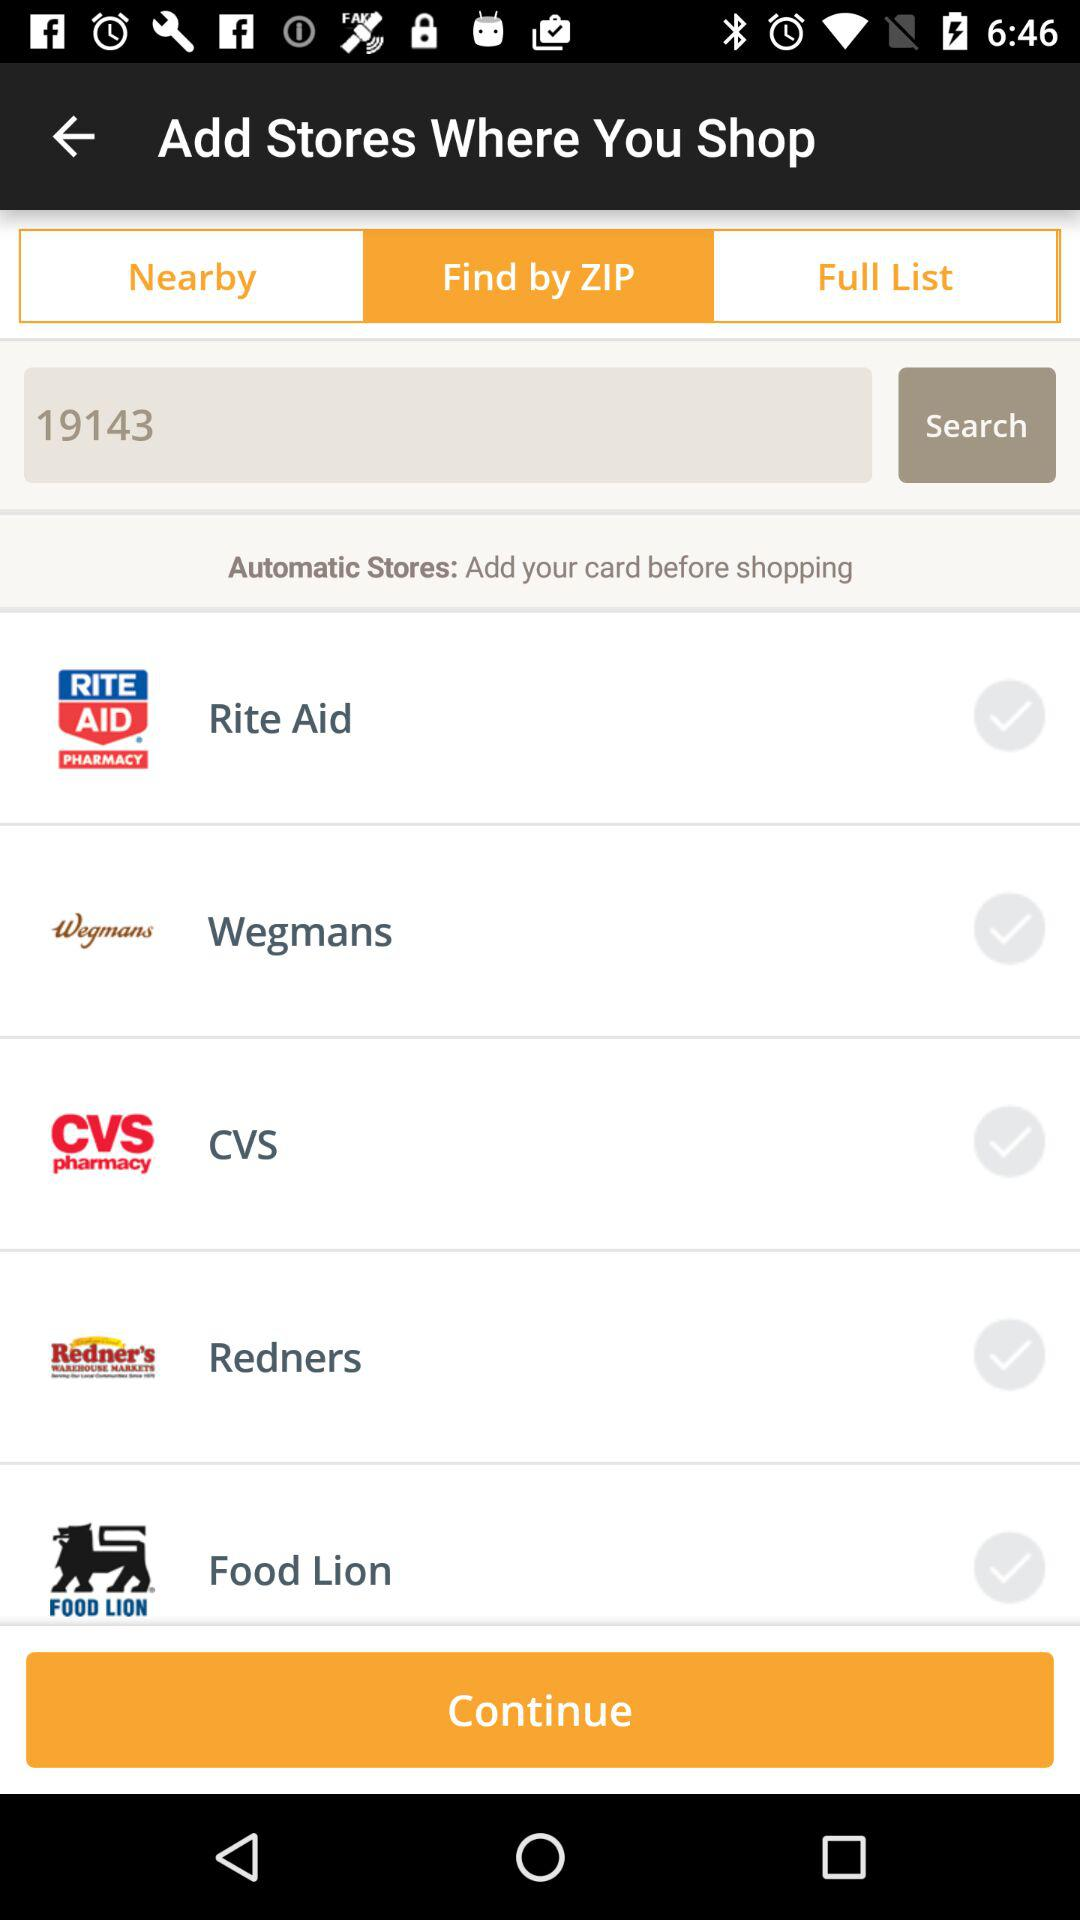What is the ZIP code? The ZIP code is 19143. 